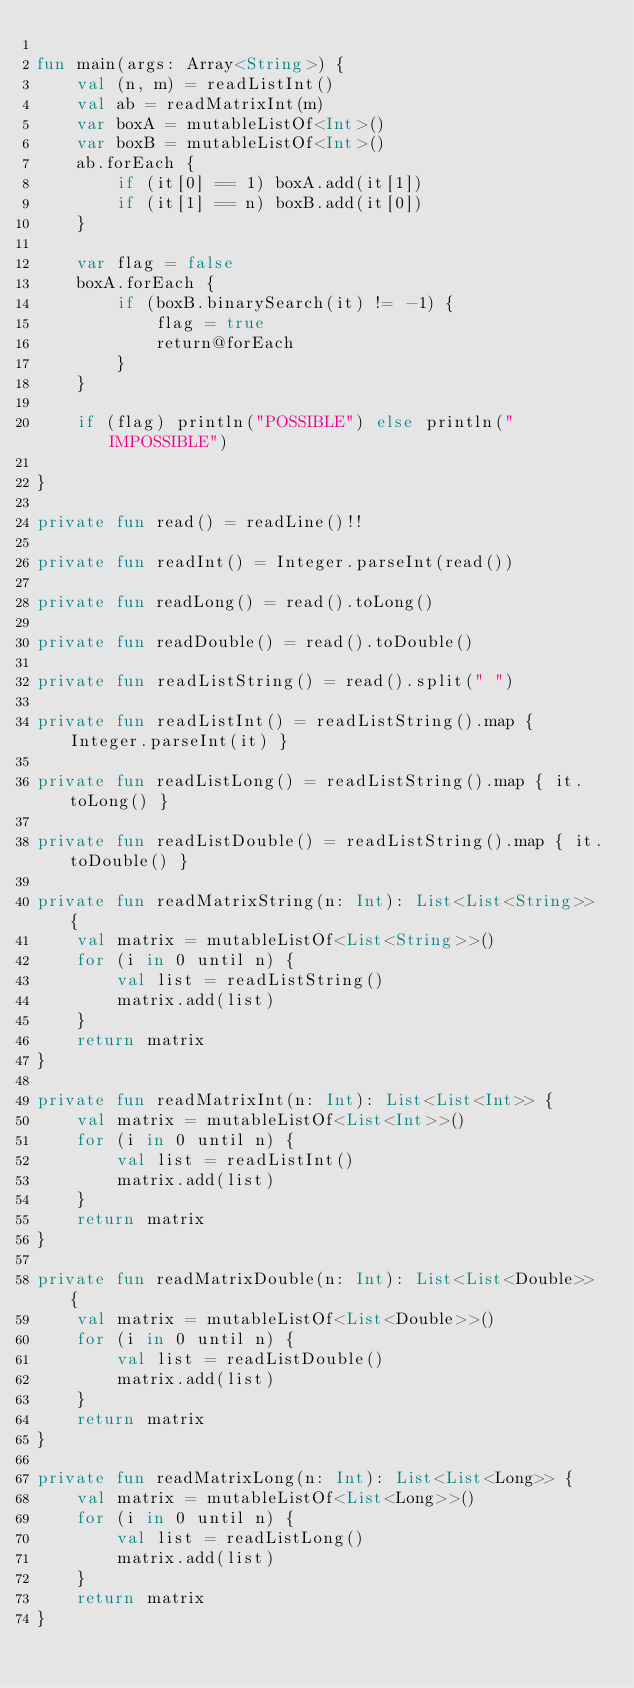<code> <loc_0><loc_0><loc_500><loc_500><_Kotlin_>
fun main(args: Array<String>) {
    val (n, m) = readListInt()
    val ab = readMatrixInt(m)
    var boxA = mutableListOf<Int>()
    var boxB = mutableListOf<Int>()
    ab.forEach {
        if (it[0] == 1) boxA.add(it[1])
        if (it[1] == n) boxB.add(it[0])
    }

    var flag = false
    boxA.forEach {
        if (boxB.binarySearch(it) != -1) {
            flag = true
            return@forEach
        }
    }

    if (flag) println("POSSIBLE") else println("IMPOSSIBLE")

}

private fun read() = readLine()!!

private fun readInt() = Integer.parseInt(read())

private fun readLong() = read().toLong()

private fun readDouble() = read().toDouble()

private fun readListString() = read().split(" ")

private fun readListInt() = readListString().map { Integer.parseInt(it) }

private fun readListLong() = readListString().map { it.toLong() }

private fun readListDouble() = readListString().map { it.toDouble() }

private fun readMatrixString(n: Int): List<List<String>> {
    val matrix = mutableListOf<List<String>>()
    for (i in 0 until n) {
        val list = readListString()
        matrix.add(list)
    }
    return matrix
}

private fun readMatrixInt(n: Int): List<List<Int>> {
    val matrix = mutableListOf<List<Int>>()
    for (i in 0 until n) {
        val list = readListInt()
        matrix.add(list)
    }
    return matrix
}

private fun readMatrixDouble(n: Int): List<List<Double>> {
    val matrix = mutableListOf<List<Double>>()
    for (i in 0 until n) {
        val list = readListDouble()
        matrix.add(list)
    }
    return matrix
}

private fun readMatrixLong(n: Int): List<List<Long>> {
    val matrix = mutableListOf<List<Long>>()
    for (i in 0 until n) {
        val list = readListLong()
        matrix.add(list)
    }
    return matrix
}

</code> 